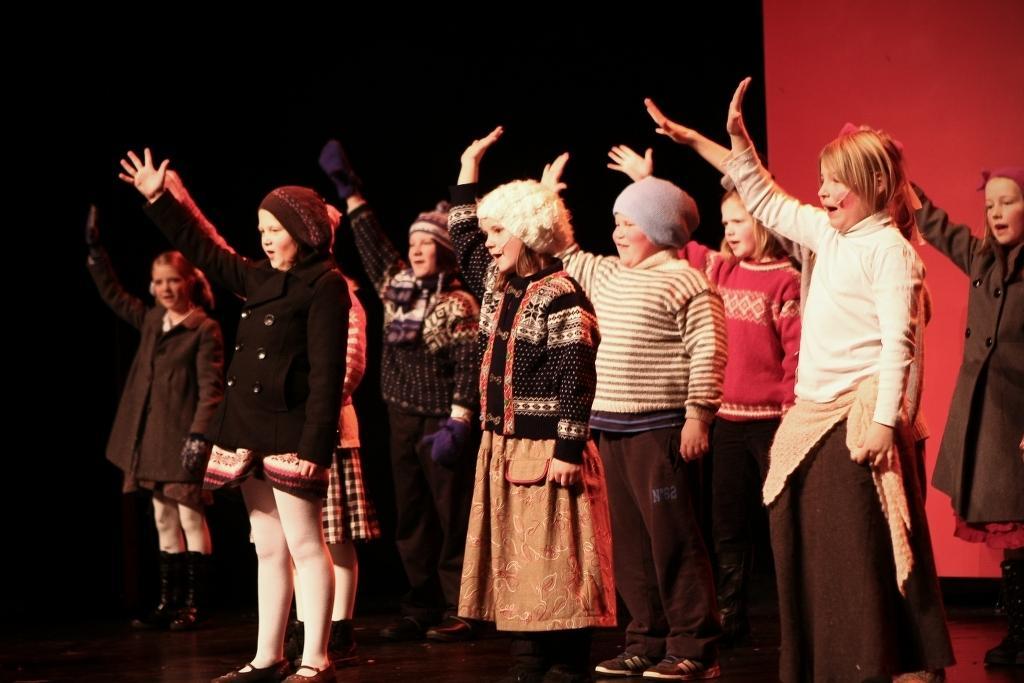Could you give a brief overview of what you see in this image? In this image, we can see a group of kids are standing and raising their hand. Few are smiling. Background we can see black and red color. 